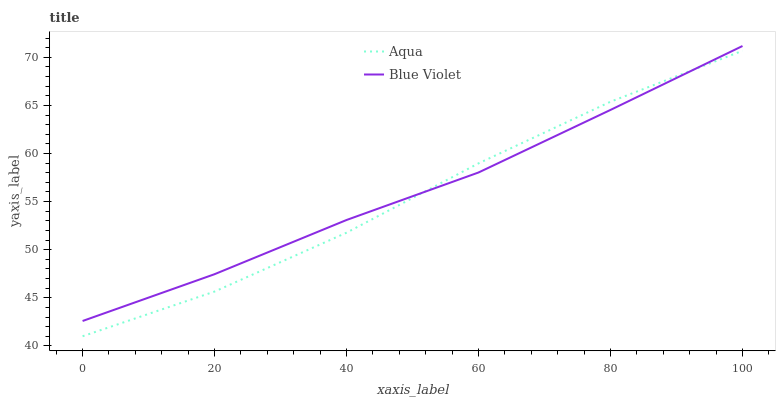Does Blue Violet have the minimum area under the curve?
Answer yes or no. No. Is Blue Violet the roughest?
Answer yes or no. No. Does Blue Violet have the lowest value?
Answer yes or no. No. 